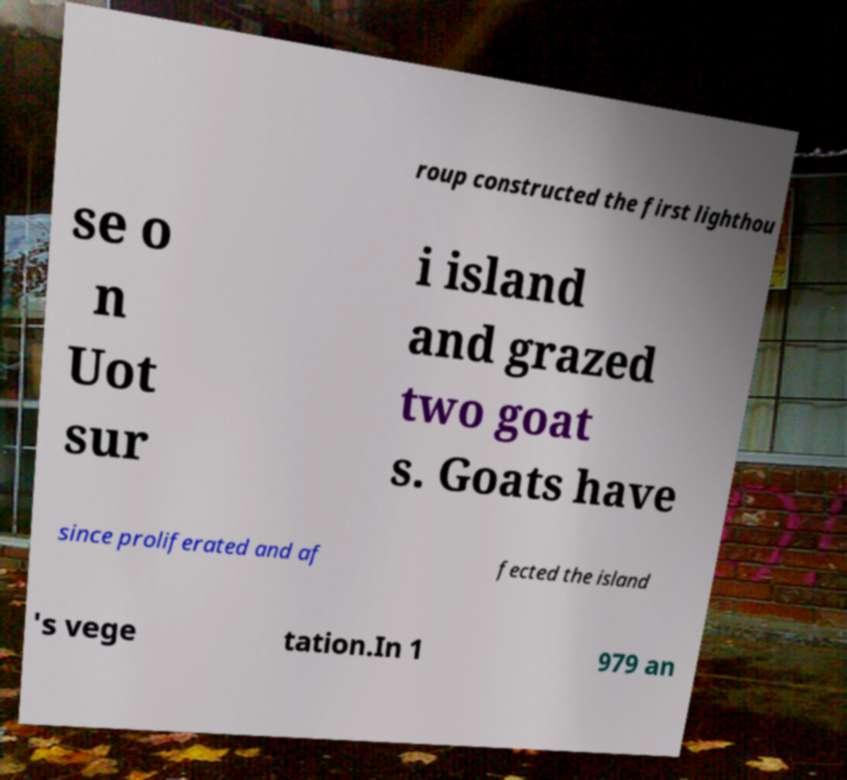What messages or text are displayed in this image? I need them in a readable, typed format. roup constructed the first lighthou se o n Uot sur i island and grazed two goat s. Goats have since proliferated and af fected the island 's vege tation.In 1 979 an 